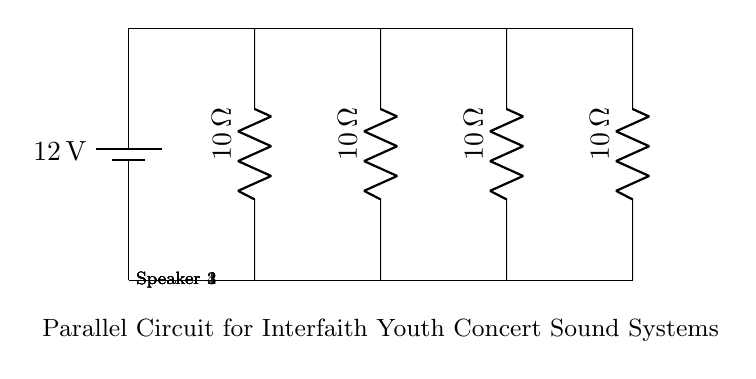What is the total voltage in the circuit? The circuit shows a battery labeled with 12V as its voltage. In a parallel circuit, all components receive the same voltage from the source. Therefore, the total voltage is the battery voltage.
Answer: 12 volts How many speakers are connected in this circuit? The diagram displays four resistors, each labeled as a speaker. Counting these components gives us the total number of speakers connected.
Answer: Four What is the resistance of each speaker? Each resistor in the circuit is labeled with a resistance of 10 ohms. This is a direct observation from the labeled components in the diagram.
Answer: 10 ohms What circuit configuration is illustrated? The connection of multiple components in separate branches indicates a parallel circuit, where voltage across each component is the same. This contrasts with series configurations.
Answer: Parallel What is the equivalent resistance of the circuit? To find the equivalent resistance in a parallel circuit, you use the formula: 1/R_eq = 1/R1 + 1/R2 + 1/R3 + 1/R4. Since each resistor is 10 ohms, it results in an equivalent resistance of 2.5 ohms after solving the equation.
Answer: 2.5 ohms What happens to the voltage across each speaker? In a parallel circuit, each speaker receives the full supply voltage, which is also the battery voltage. This means that regardless of how many speakers are present, they all experience the same voltage.
Answer: 12 volts How does increasing the number of speakers affect the overall current? Adding more speakers in parallel reduces the overall resistance, which increases the total current drawn from the source by Ohm’s law. Since the voltage remains constant, the current increases with additional parallel branches.
Answer: Increases 